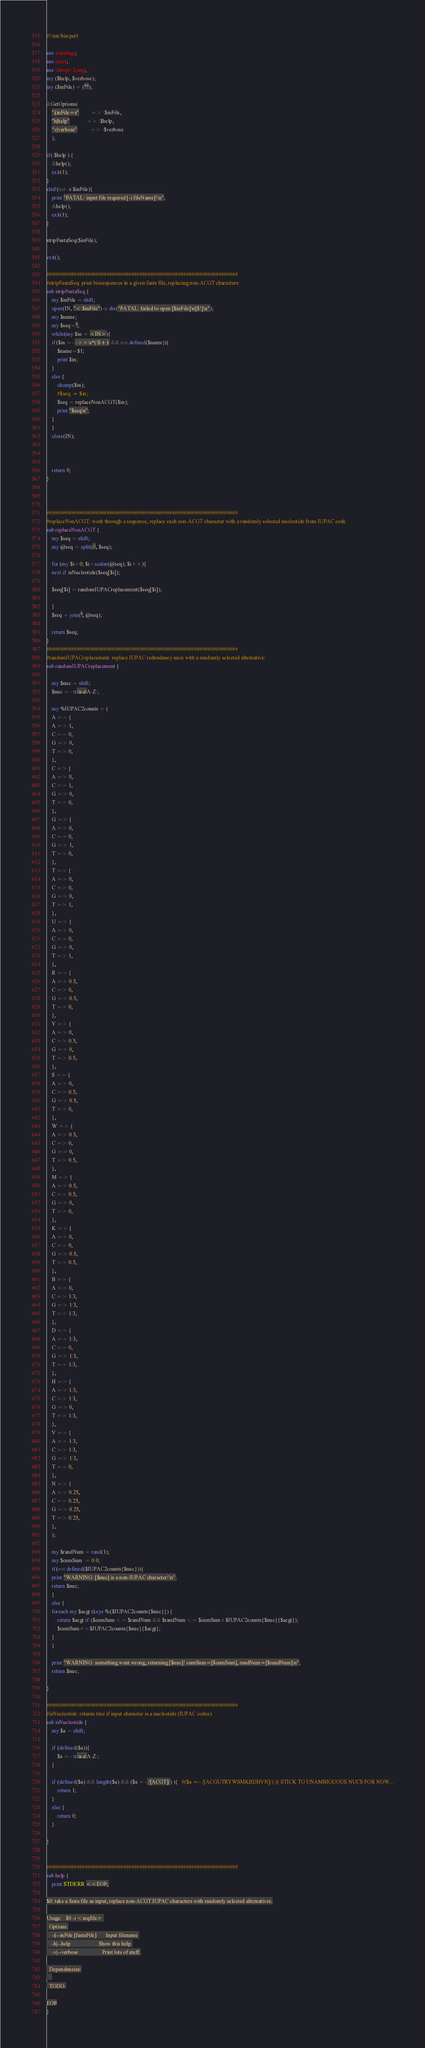<code> <loc_0><loc_0><loc_500><loc_500><_Perl_>#!/usr/bin/perl

use warnings;
use strict;
use Getopt::Long;
my ($help, $verbose); 
my ($inFile) = (""); 

&GetOptions(
    "i|inFile=s"         => \$inFile,
    "h|help"             => \$help,
    "v|verbose"          => \$verbose
    );

if( $help ) {
    &help();
    exit(1);
}
elsif(not -s $inFile){
    print "FATAL: input file required [-i fileName]!\n";
    &help();
    exit(1);
}

stripFastaSeq($inFile);

exit(); 

######################################################################
#stripFastaSeq: print biosequences in a given fasta file, replacing non-ACGT characters: 
sub stripFastaSeq {
    my $inFile = shift;
    open(IN, "< $inFile") or die("FATAL: failed to open [$inFile]\n[$!]\n");
    my $name;
    my $seq='';
    while(my $in = <IN>){
	if($in =~ /^>\s*(\S+)/ && not defined($name)){
	    $name=$1;
	    print $in;
	}
	else {
	    chomp($in);
	    #$seq .= $in;
	    $seq = replaceNonACGT($in);
	    print "$seq\n";
	}
    }
    close(IN);
    
    
    
    return 0; 
}



######################################################################
#replaceNonACGT: work through a sequence, replace each non-ACGT character with a randomly selected nucleotide from IUPAC code 
sub replaceNonACGT {
    my $seq = shift;
    my @seq = split(//, $seq);

    for (my $i=0; $i<scalar(@seq); $i++){
	next if isNucleotide($seq[$i]);
	
	$seq[$i] = randomIUPACreplacement($seq[$i]); 
	
    }
    $seq = join('', @seq);
    
    return $seq; 
}
######################################################################
#randomIUPACreplacement: replace IUPAC redundancy nucs with a randomly selected alternative:
sub randomIUPACreplacement {
    
    my $nuc = shift; 
    $nuc =~ tr/a-z/A-Z/;
    
    my %IUPAC2counts = (
    A => {
	A => 1,
	C => 0,
	G => 0,
	T => 0,
    },
    C => {
	A => 0,
	C => 1,
	G => 0,
	T => 0,
    },
    G => {
	A => 0,
	C => 0,
	G => 1,
	T => 0,
    },
    T => {
	A => 0,
	C => 0,
	G => 0,
	T => 1,
    },
    U => {
	A => 0,
	C => 0,
	G => 0,
	T => 1,
    },
    R => {
	A => 0.5,
	C => 0,
	G => 0.5,
	T => 0,
    },
    Y => {
	A => 0,
	C => 0.5,
	G => 0,
	T => 0.5,
    },
    S => {
	A => 0,
	C => 0.5,
	G => 0.5,
	T => 0,
    },
    W => {
	A => 0.5,
	C => 0,
	G => 0,
	T => 0.5,
    },
    M => {
	A => 0.5,
	C => 0.5,
	G => 0,
	T => 0,
    },
    K => {
	A => 0,
	C => 0,
	G => 0.5,
	T => 0.5,
    },
    B => {
	A => 0,
	C => 1/3,
	G => 1/3,
	T => 1/3,
    },
    D => {
	A => 1/3,
	C => 0,
	G => 1/3,
	T => 1/3,
    },
    H => {
	A => 1/3,
	C => 1/3,
	G => 0,
	T => 1/3,
    },
    V => {
	A => 1/3,
	C => 1/3,
	G => 1/3,
	T => 0,
    },
    N => {
	A => 0.25,
	C => 0.25,
	G => 0.25,
	T => 0.25,
    },
    );
    
    my $randNum = rand(1);
    my $cumSum  = 0.0; 
    if(not defined($IUPAC2counts{$nuc})){
	print "WARNING: [$nuc] is a non-IUPAC character!\n";
	return $nuc; 	    
    }
    else {
	foreach my $acgt (keys %{$IUPAC2counts{$nuc}}) {
	    return $acgt if ($cumSum <= $randNum && $randNum <= $cumSum+$IUPAC2counts{$nuc}{$acgt});
	    $cumSum+=$IUPAC2counts{$nuc}{$acgt};
	}
    }
    
    print "WARNING: something went wrong, returning [$nuc]! cumSum=[$cumSum], randNum=[$randNum]\n";
    return $nuc;
    
}

######################################################################
#isNucleotide: returns true if input character is a nucleotide (IUPAC codes):
sub isNucleotide {
    my $a = shift;
    
    if (defined($a)){
        $a =~ tr/a-z/A-Z/;
    }
    
    if (defined($a) && length($a) && ($a =~ /[ACGT]/) ){   #($a =~ /[ACGUTRYWSMKBDHVN]/) ){ STICK TO UNAMBIGUOUS NUCS FOR NOW...
        return 1;
    }
    else {
        return 0;
    }
    
}


######################################################################
sub help {
    print STDERR <<EOF;

$0: take a fasta file as input, replace non-ACGT IUPAC characters with randomly selected alternatives.

Usage:   $0 -i <seqfile> 
  Options:
    -i|--inFile [fastaFile]       Input filename 
    -h|--help                     Show this help.
    -v|--verbose                  Print lots of stuff.

  Dependencies:
    
  TODO:

EOF
}


</code> 